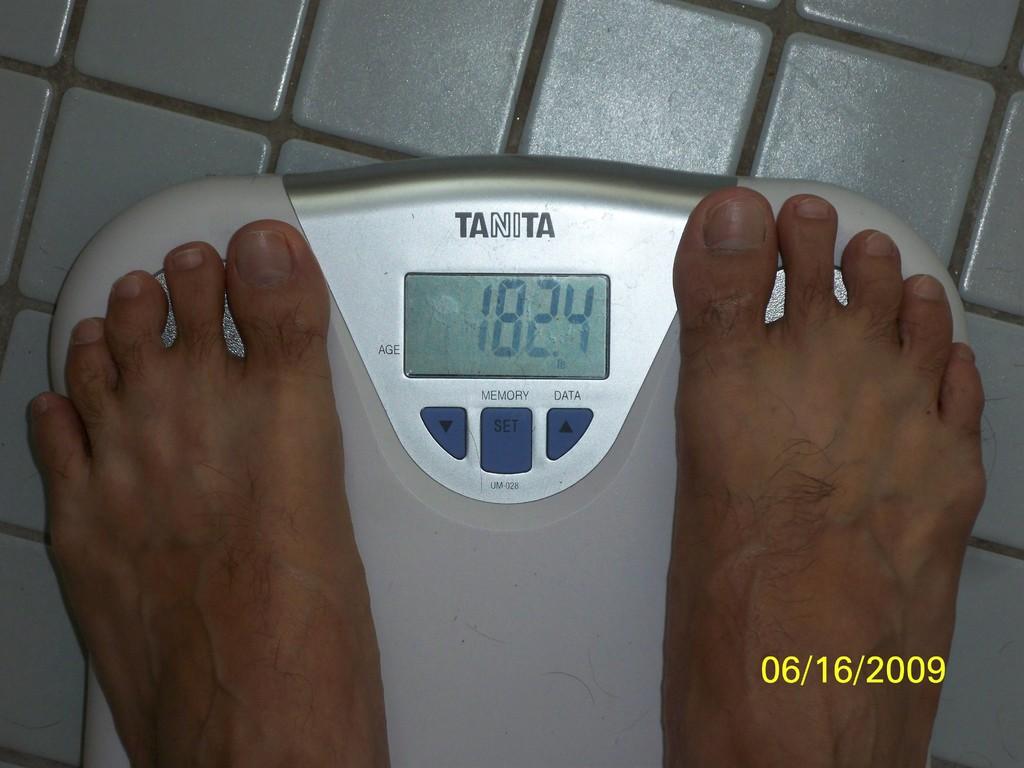What is the word under the word memory on the scales?
Keep it short and to the point. Set. 